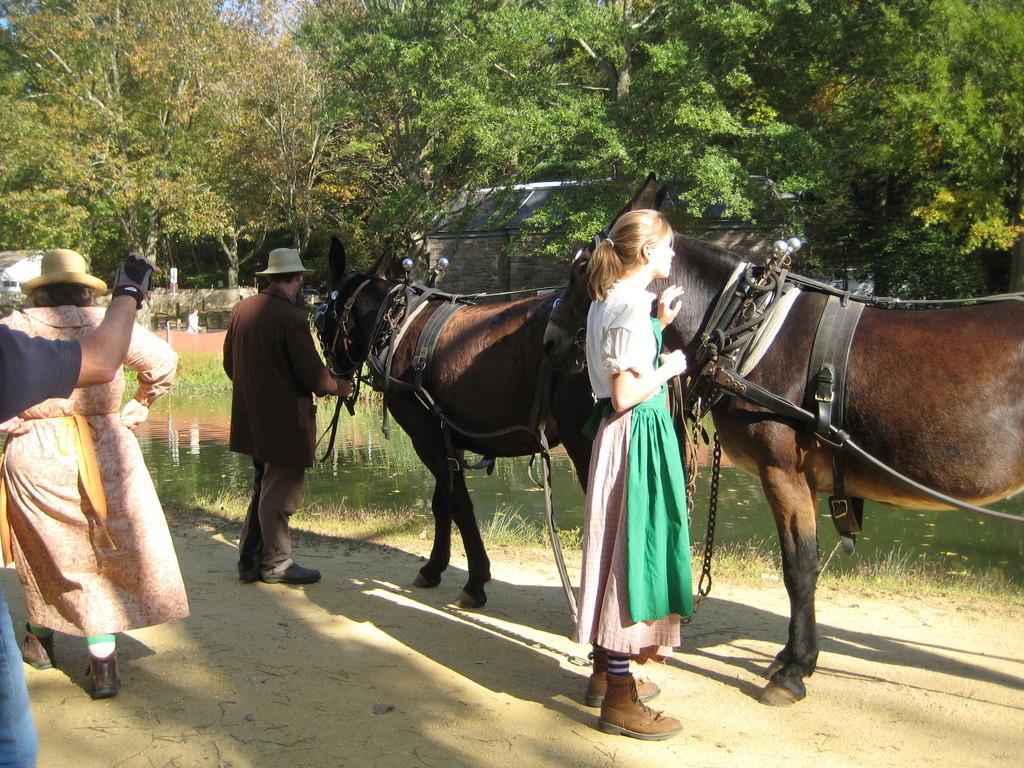Describe this image in one or two sentences. There are two horses. On the horses there are saddles. Two persons are standing. A man is wearing a cap. There are two ladies on the left side. In the background there are trees and water. 